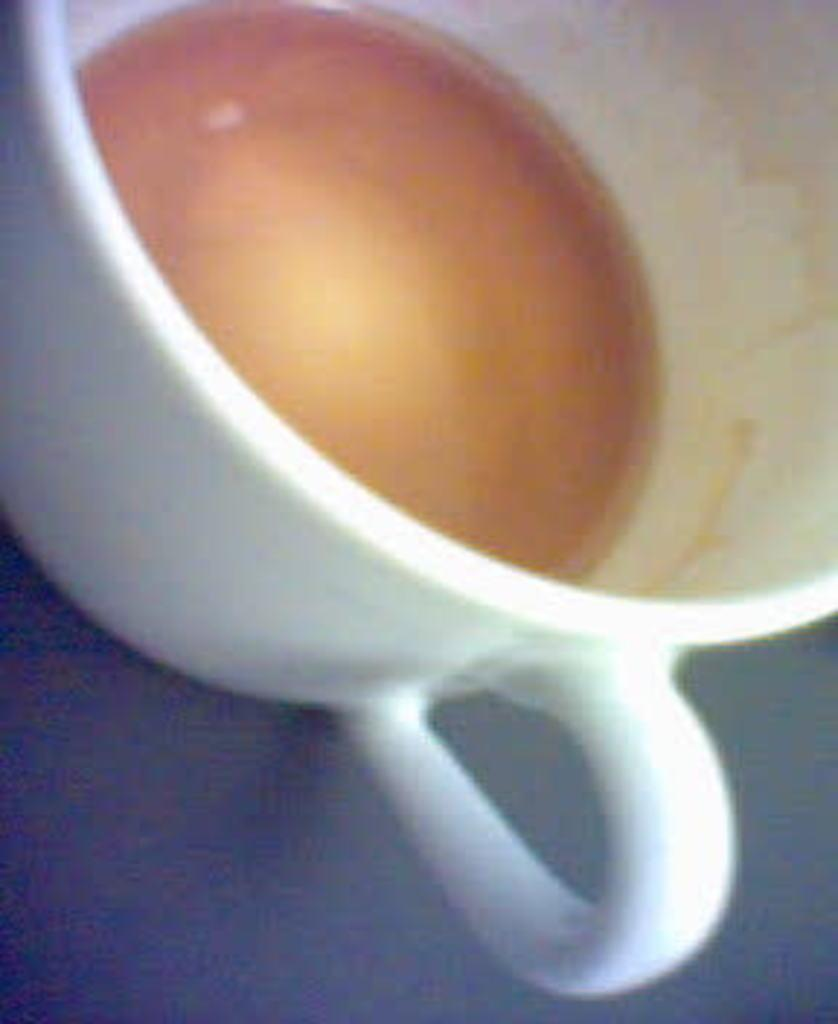What object is present in the image? There is a cup in the image. What is inside the cup? The cup contains liquid. What is the price of the sugar in the image? There is no sugar present in the image, so it is not possible to determine its price. 